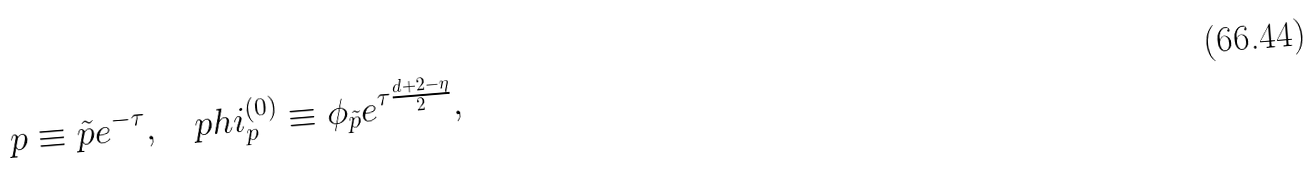Convert formula to latex. <formula><loc_0><loc_0><loc_500><loc_500>p \equiv \tilde { p } e ^ { - \tau } , \quad p h i _ { p } ^ { ( 0 ) } \equiv \phi _ { \tilde { p } } e ^ { \tau \frac { d + 2 - \eta } { 2 } } ,</formula> 